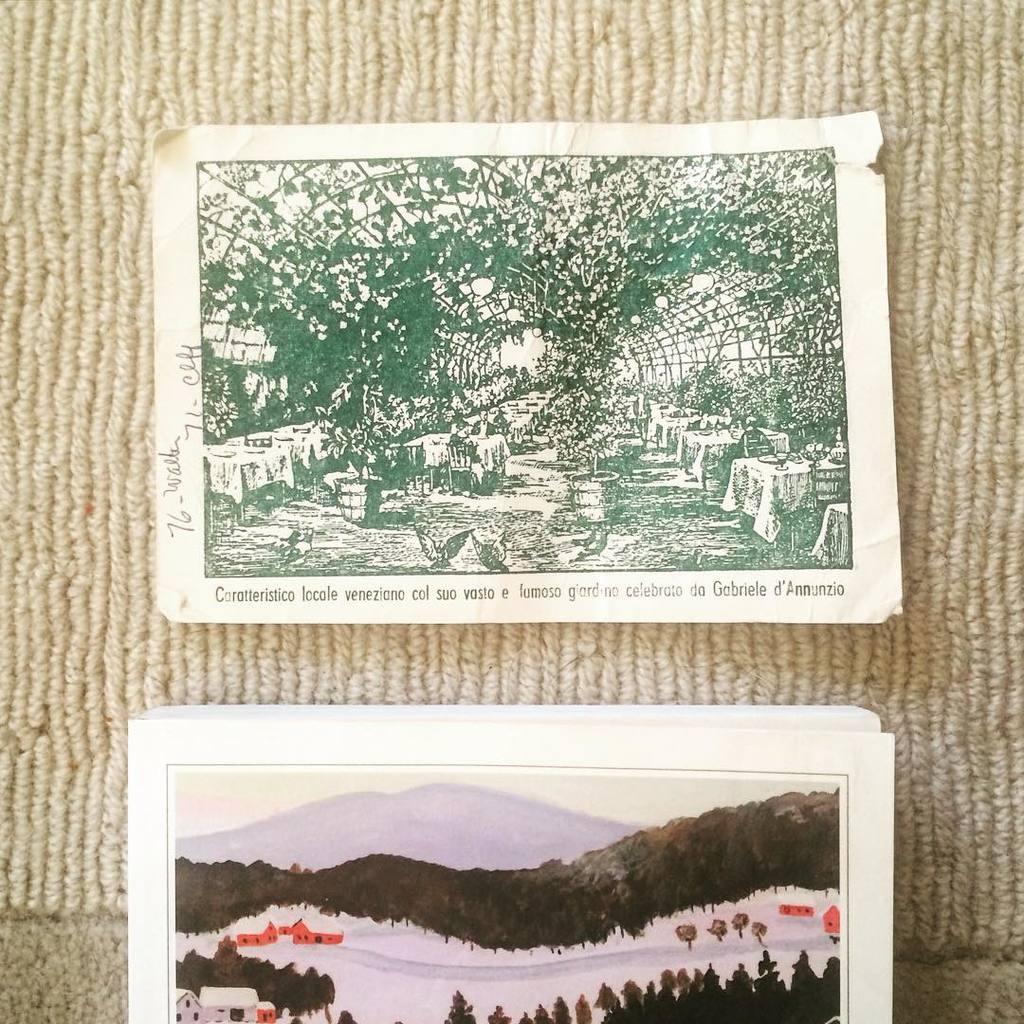In one or two sentences, can you explain what this image depicts? In this image I can see two photos on the cloth. In these photos I can see mountains, house, trees, the sky, tables and other objects. The photo on the above is black and white in color and something written on it. 